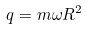Convert formula to latex. <formula><loc_0><loc_0><loc_500><loc_500>q = { m \omega } R ^ { 2 }</formula> 